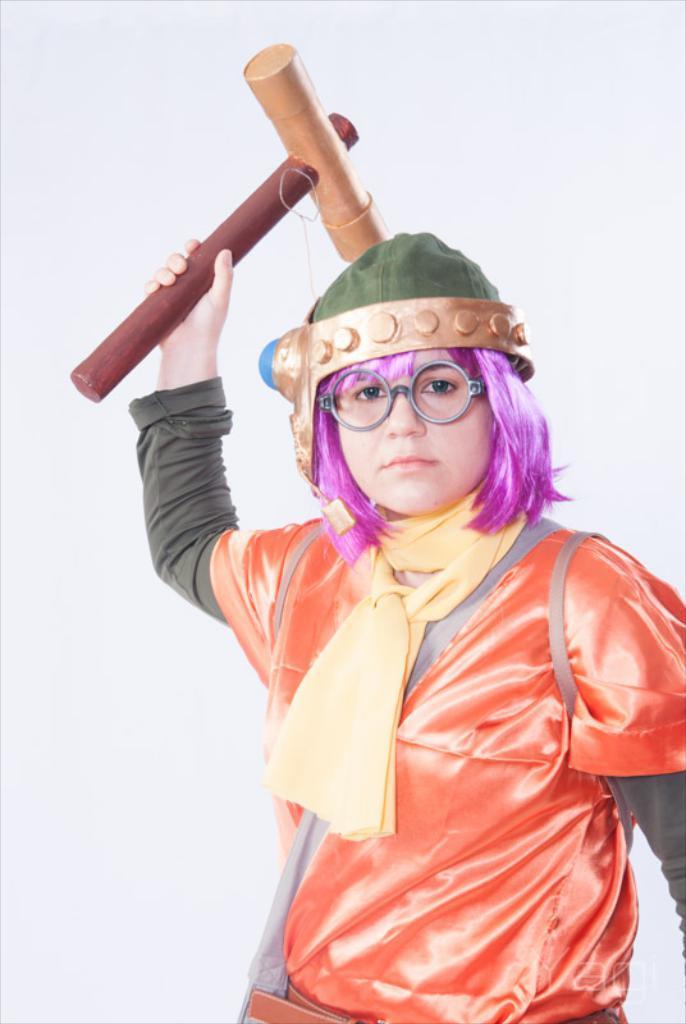How would you summarize this image in a sentence or two? In this picture we can see a woman holding a hammer with her hand and there is a white background. 